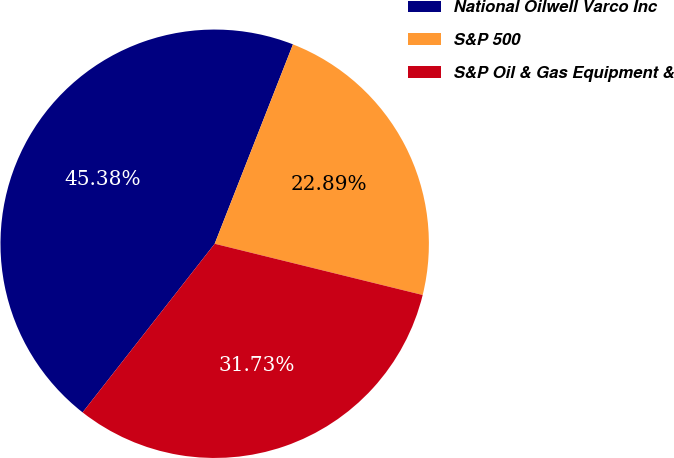Convert chart to OTSL. <chart><loc_0><loc_0><loc_500><loc_500><pie_chart><fcel>National Oilwell Varco Inc<fcel>S&P 500<fcel>S&P Oil & Gas Equipment &<nl><fcel>45.38%<fcel>22.89%<fcel>31.73%<nl></chart> 